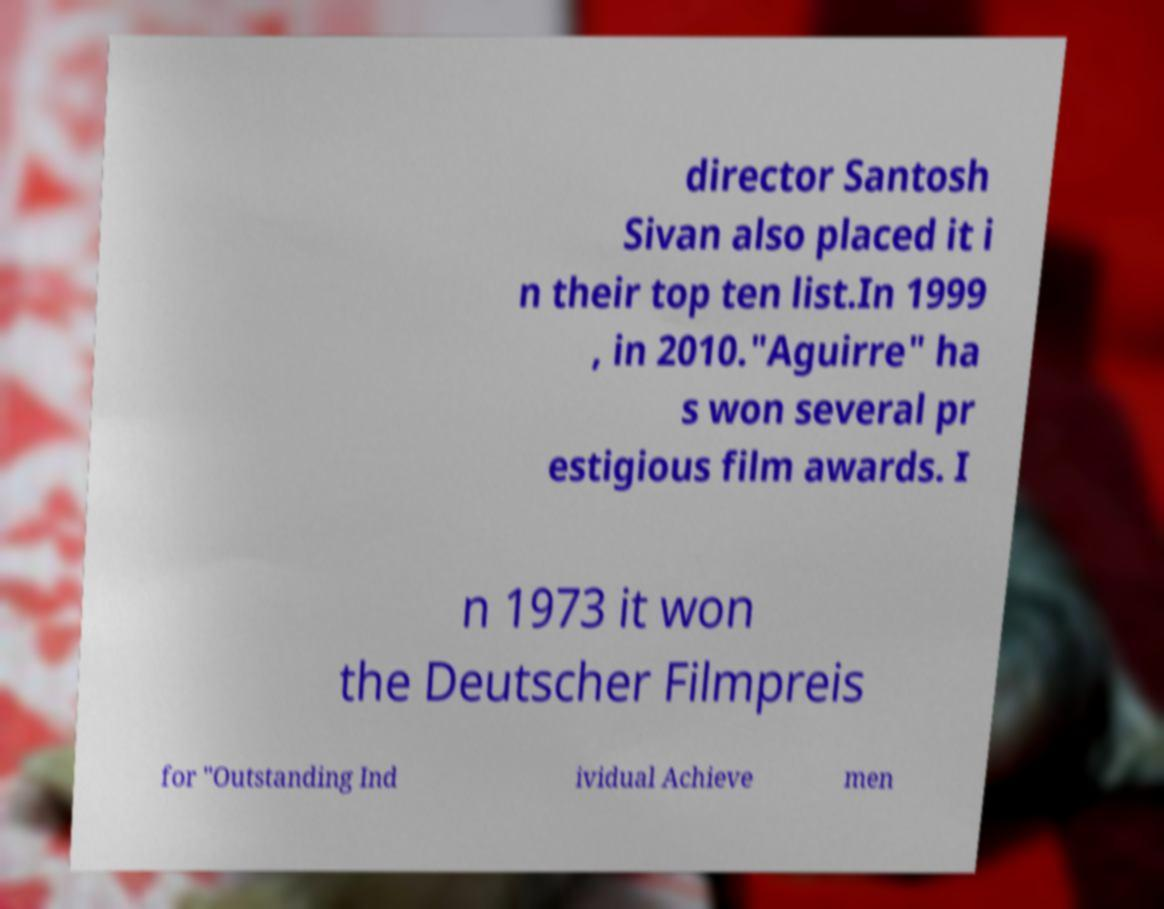Can you accurately transcribe the text from the provided image for me? director Santosh Sivan also placed it i n their top ten list.In 1999 , in 2010."Aguirre" ha s won several pr estigious film awards. I n 1973 it won the Deutscher Filmpreis for "Outstanding Ind ividual Achieve men 